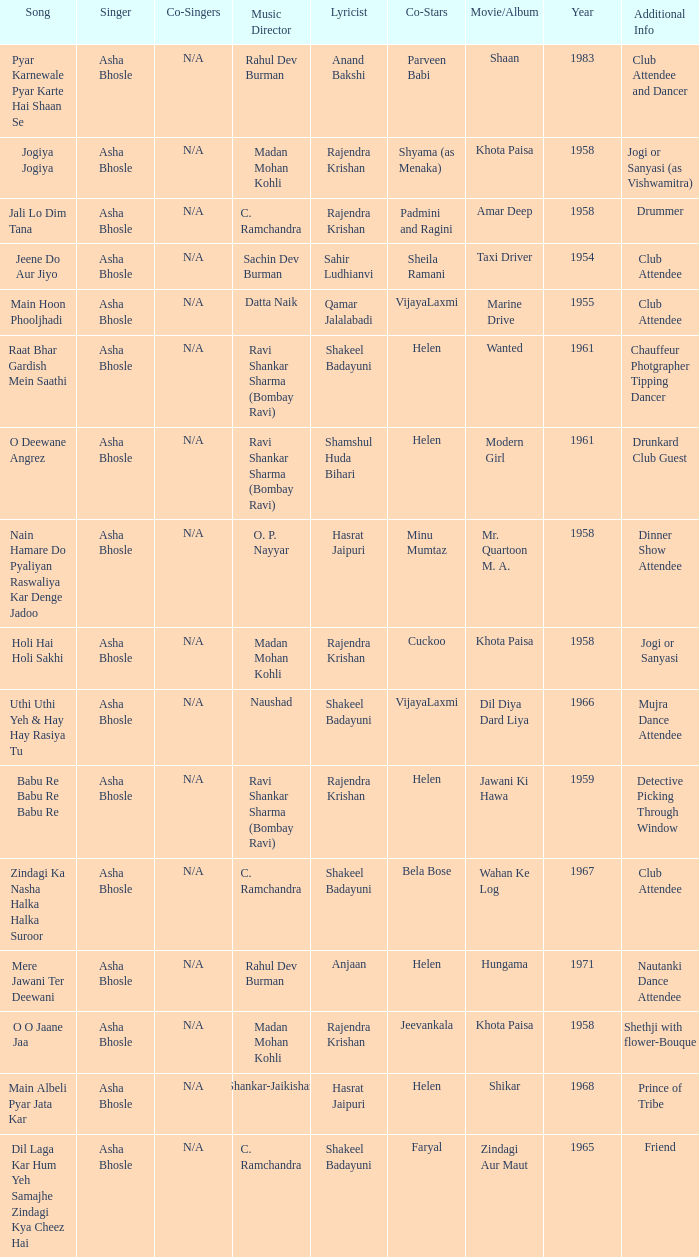What movie did Vijayalaxmi Co-star in and Shakeel Badayuni write the lyrics? Dil Diya Dard Liya. 